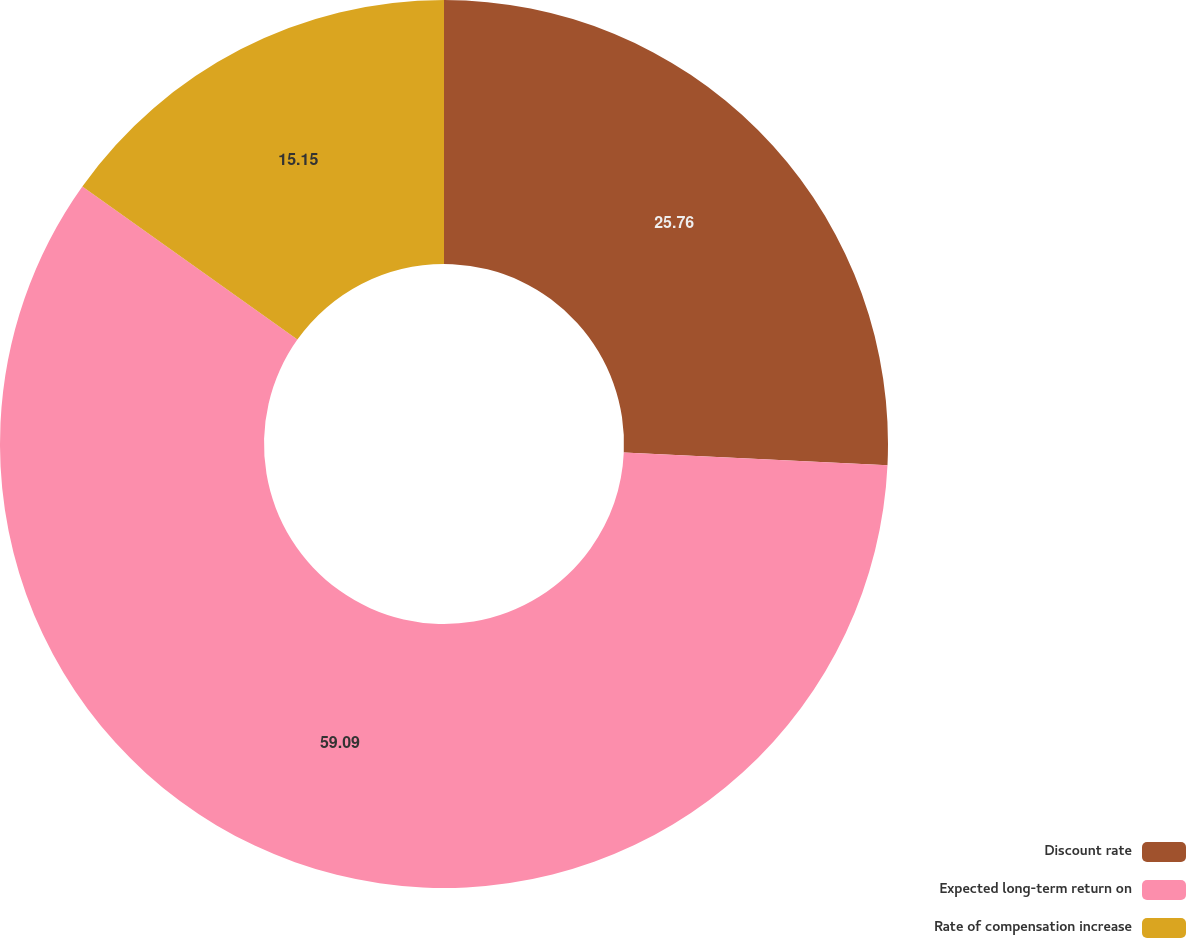Convert chart. <chart><loc_0><loc_0><loc_500><loc_500><pie_chart><fcel>Discount rate<fcel>Expected long-term return on<fcel>Rate of compensation increase<nl><fcel>25.76%<fcel>59.09%<fcel>15.15%<nl></chart> 